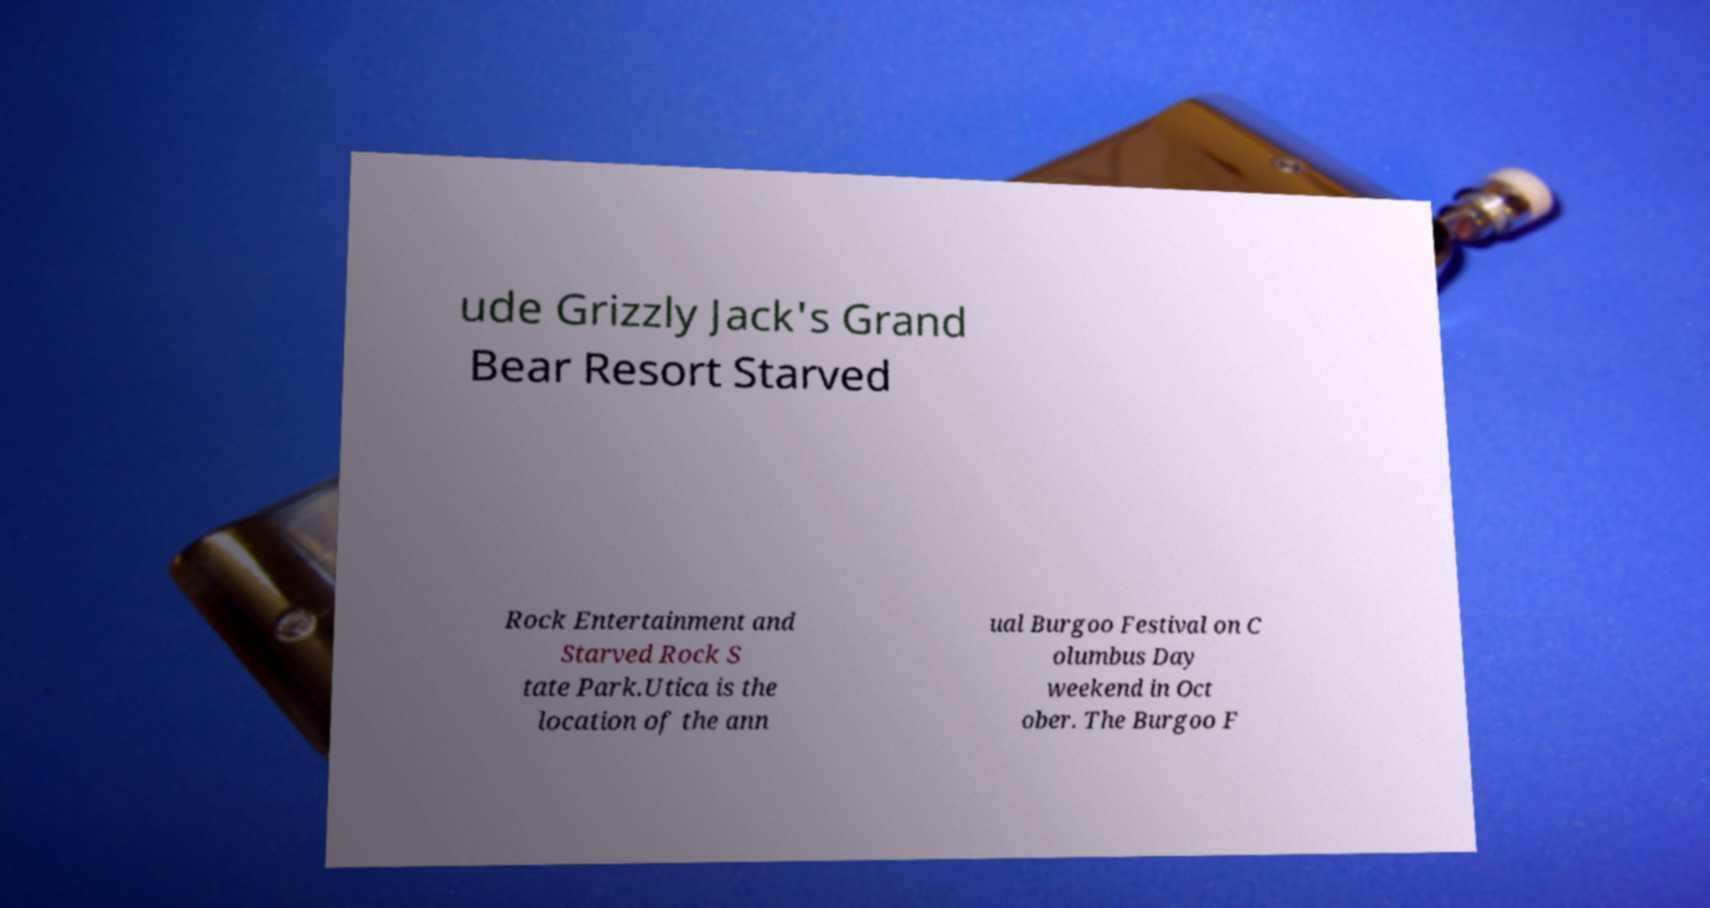Could you assist in decoding the text presented in this image and type it out clearly? ude Grizzly Jack's Grand Bear Resort Starved Rock Entertainment and Starved Rock S tate Park.Utica is the location of the ann ual Burgoo Festival on C olumbus Day weekend in Oct ober. The Burgoo F 